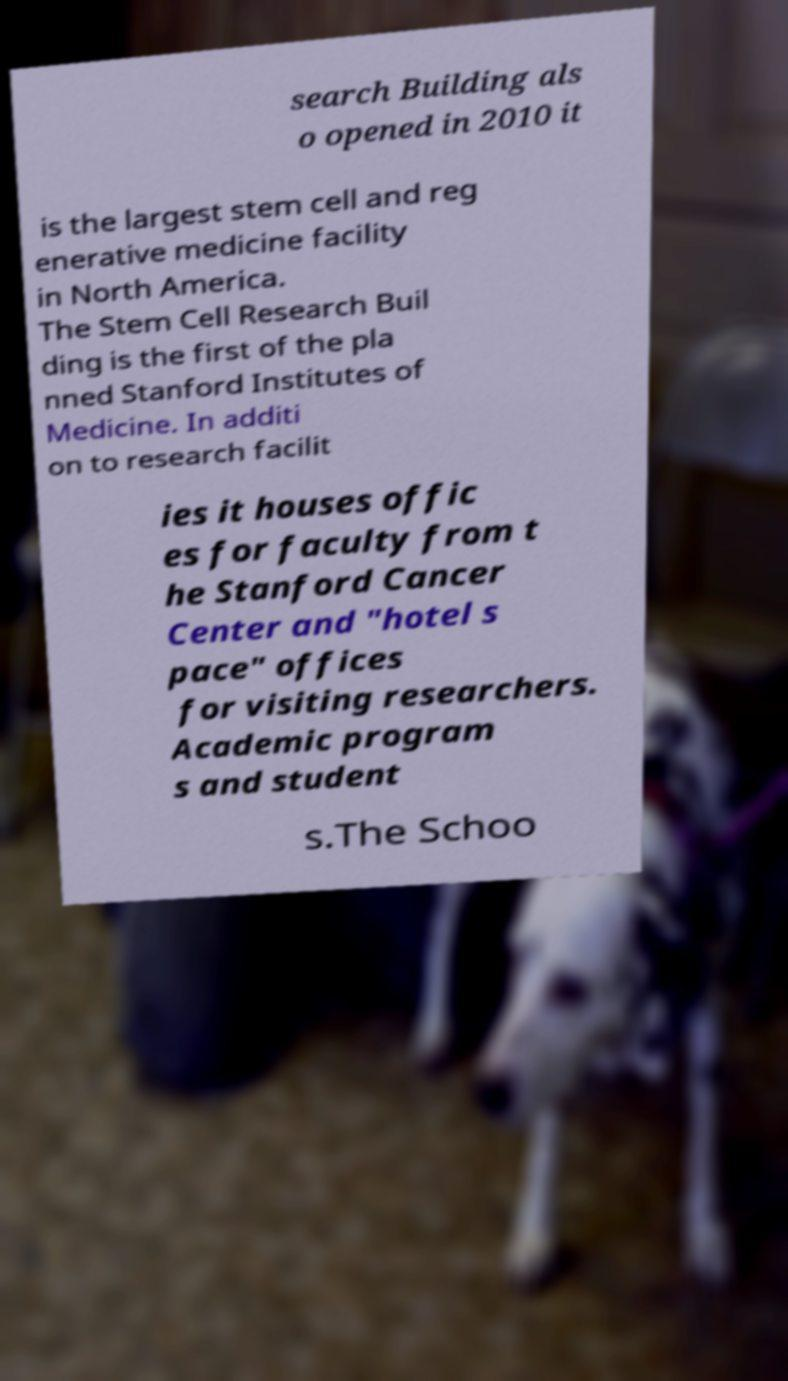For documentation purposes, I need the text within this image transcribed. Could you provide that? search Building als o opened in 2010 it is the largest stem cell and reg enerative medicine facility in North America. The Stem Cell Research Buil ding is the first of the pla nned Stanford Institutes of Medicine. In additi on to research facilit ies it houses offic es for faculty from t he Stanford Cancer Center and "hotel s pace" offices for visiting researchers. Academic program s and student s.The Schoo 